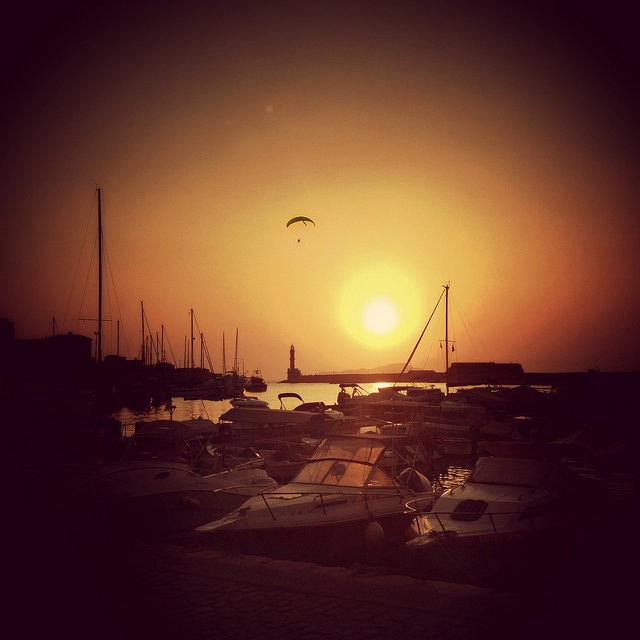Describe the objects in this image and their specific colors. I can see boat in black, maroon, and brown tones, boat in black, maroon, and brown tones, boat in black, maroon, and brown tones, boat in black, maroon, tan, and brown tones, and boat in black, maroon, and brown tones in this image. 